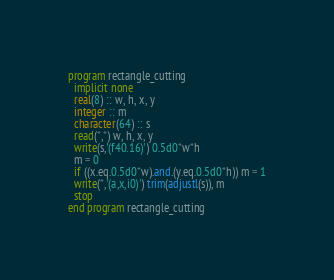<code> <loc_0><loc_0><loc_500><loc_500><_FORTRAN_>program rectangle_cutting
  implicit none
  real(8) :: w, h, x, y
  integer :: m
  character(64) :: s
  read(*,*) w, h, x, y
  write(s,'(f40.16)') 0.5d0*w*h
  m = 0
  if ((x.eq.0.5d0*w).and.(y.eq.0.5d0*h)) m = 1
  write(*,'(a,x,i0)') trim(adjustl(s)), m
  stop
end program rectangle_cutting</code> 